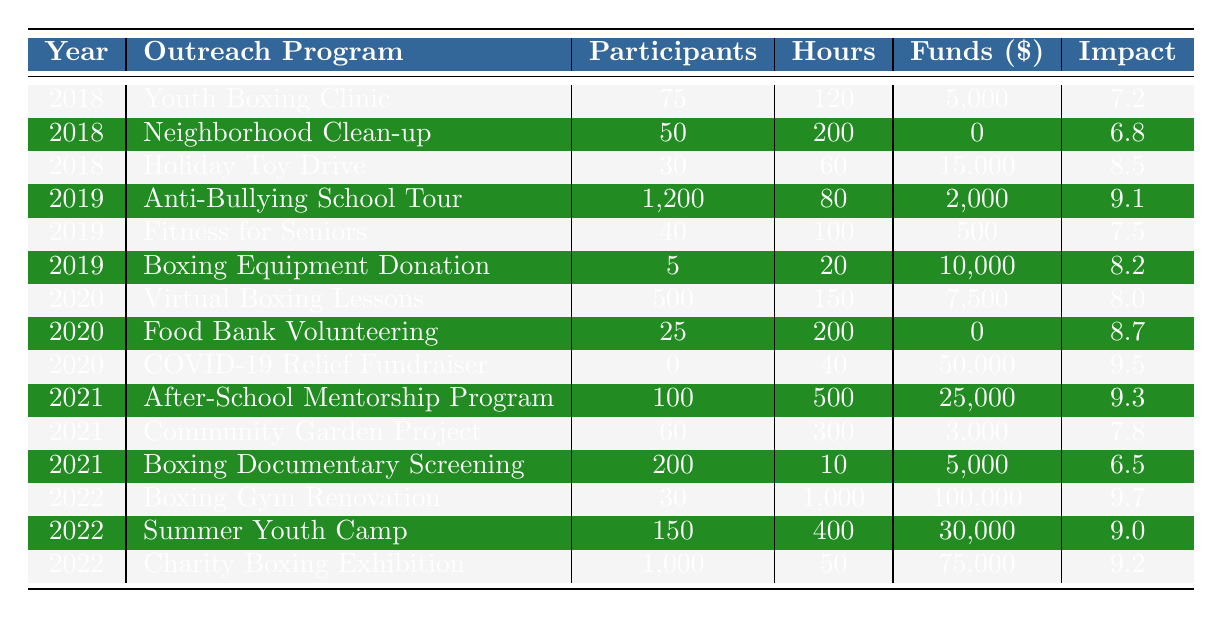What was the total amount of funds raised in 2018 across all outreach programs? To find the total funds raised in 2018, we add the funds from each program: 5,000 (Youth Boxing Clinic) + 0 (Neighborhood Clean-up) + 15,000 (Holiday Toy Drive) = 20,000.
Answer: 20,000 Which outreach program had the highest community impact score? By reviewing the Community Impact Score column, the highest score is 9.7 for the Boxing Gym Renovation in 2022.
Answer: Boxing Gym Renovation How many total participants were involved in community outreach activities in 2021? Adding the number of participants across all programs in 2021: 100 (After-School Mentorship Program) + 60 (Community Garden Project) + 200 (Boxing Documentary Screening) = 360.
Answer: 360 Did the number of participants increase from 2018 to 2019? In 2018, the total participants were 75 + 50 + 30 = 155. In 2019, the total participants were 1200 + 40 + 5 = 1245. Since 1245 is greater than 155, the number increased.
Answer: Yes What is the average community impact score from 2018 to 2022? The community impact scores are 7.2, 6.8, 8.5 for 2018; 9.1, 7.5, 8.2 for 2019; 8.0, 8.7, 9.5 for 2020; 9.3, 7.8, 6.5 for 2021; and 9.7, 9.0, 9.2 for 2022. Totaling them gives 7.2 + 6.8 + 8.5 + 9.1 + 7.5 + 8.2 + 8.0 + 8.7 + 9.5 + 9.3 + 7.8 + 6.5 + 9.7 + 9.0 + 9.2 = 132.9. There are 15 scores, so the average is 132.9 / 15 = 8.86.
Answer: 8.86 What was the total number of hours volunteered in 2020? To find the total hours volunteered in 2020, we add the hours for each program: 150 (Virtual Boxing Lessons) + 200 (Food Bank Volunteering) + 40 (COVID-19 Relief Fundraiser) = 390.
Answer: 390 Which year had the highest number of participants across all outreach activities? The highest total participation occurs in 2019 with 1245 participants (1200 from Anti-Bullying School Tour, plus 40 from Fitness for Seniors, and 5 from Boxing Equipment Donation). Comparing totals for other years confirms this.
Answer: 2019 Did the COVID-19 Relief Fundraiser have any participants? The COVID-19 Relief Fundraiser had 0 participants as shown in the table.
Answer: No How has the total funds raised changed from 2018 to 2022? In 2018, total funds raised were 20,000. In 2022, total funds were 100,000 + 30,000 + 75,000 = 205,000. Comparing gives 205,000 - 20,000 = 185,000 increase.
Answer: Increased by 185,000 What outreach program had the highest number of participants in 2019? The outreach program with the highest participation in 2019 was the Anti-Bullying School Tour, with 1,200 participants.
Answer: Anti-Bullying School Tour Was the community impact score for the Holiday Toy Drive higher than that of the Fitness for Seniors? The Holiday Toy Drive had a community impact score of 8.5, while the Fitness for Seniors had a score of 7.5. Since 8.5 is greater than 7.5, the Holiday Toy Drive's score was higher.
Answer: Yes 